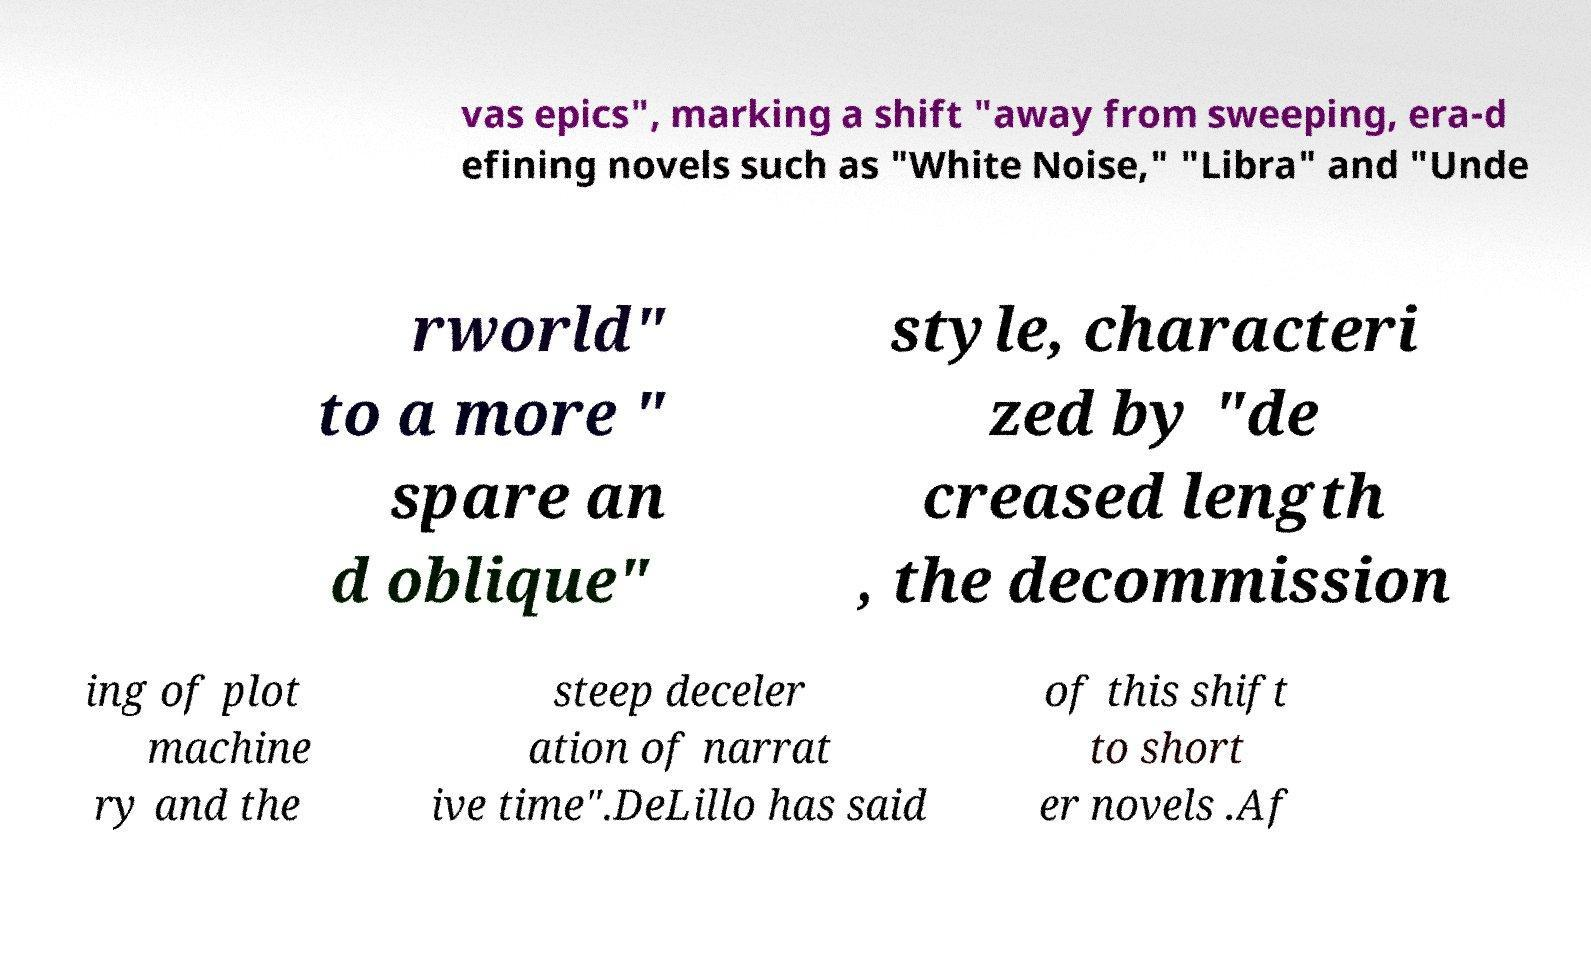I need the written content from this picture converted into text. Can you do that? vas epics", marking a shift "away from sweeping, era-d efining novels such as "White Noise," "Libra" and "Unde rworld" to a more " spare an d oblique" style, characteri zed by "de creased length , the decommission ing of plot machine ry and the steep deceler ation of narrat ive time".DeLillo has said of this shift to short er novels .Af 